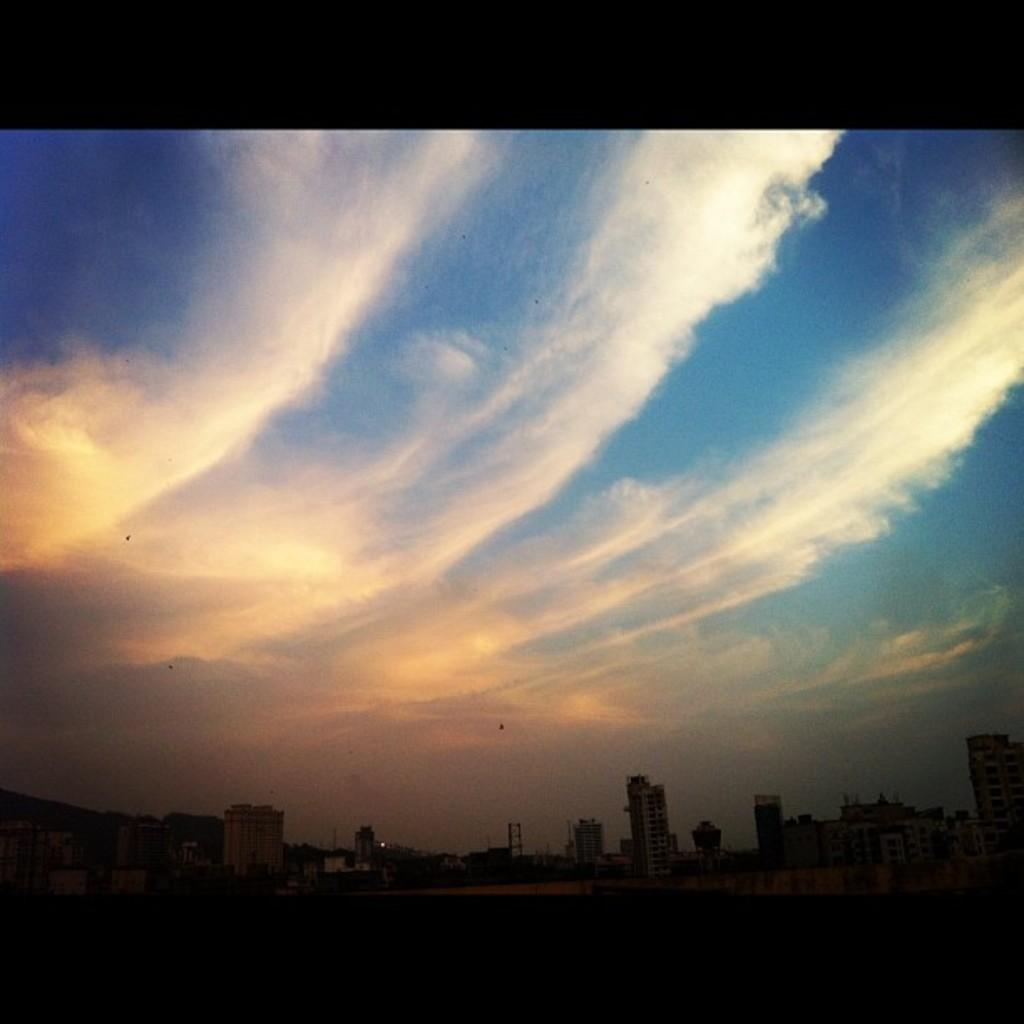What type of structures can be seen in the background of the image? There are buildings in the background of the image. What part of the natural environment is visible in the image? The sky is visible in the image. What can be observed in the sky in the image? There are clouds in the sky. What type of grape is being used to balance the buildings in the image? There is no grape present in the image, and therefore no such balancing activity can be observed. What feeling is being expressed by the clouds in the image? The clouds in the image are not expressing any feelings, as they are inanimate objects. 